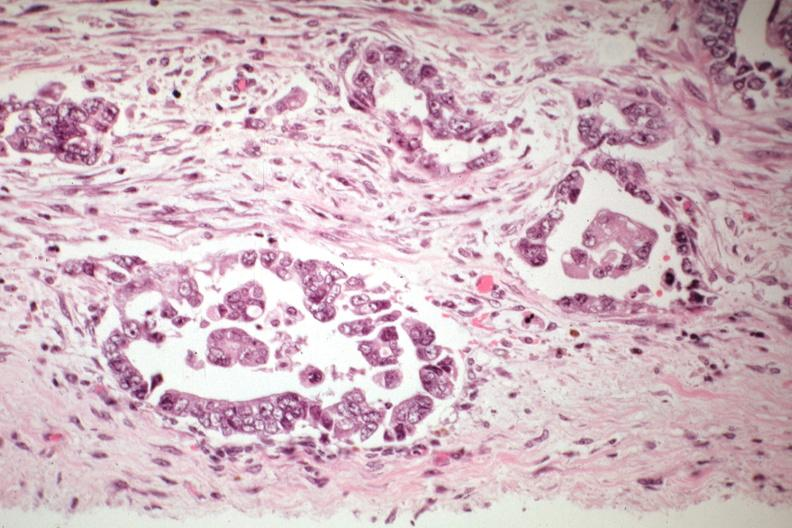what does this image show?
Answer the question using a single word or phrase. Adenocarcinoma in pelvic peritoneum 